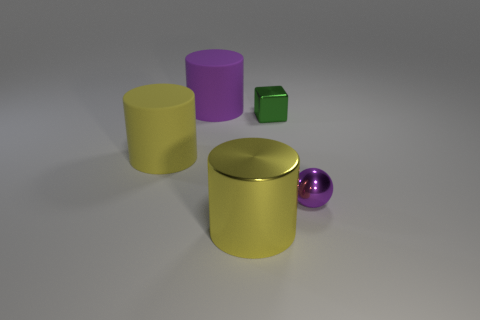Subtract all gray cylinders. Subtract all gray spheres. How many cylinders are left? 3 Add 2 big blue metallic cubes. How many objects exist? 7 Subtract all cylinders. How many objects are left? 2 Subtract all cubes. Subtract all purple metal balls. How many objects are left? 3 Add 5 tiny things. How many tiny things are left? 7 Add 1 tiny balls. How many tiny balls exist? 2 Subtract 0 gray cylinders. How many objects are left? 5 